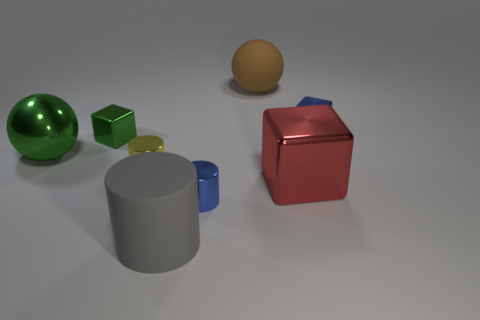Subtract all tiny green blocks. How many blocks are left? 2 Subtract all brown spheres. How many spheres are left? 1 Subtract 1 spheres. How many spheres are left? 1 Add 1 large cylinders. How many objects exist? 9 Subtract all cylinders. How many objects are left? 5 Subtract all tiny yellow rubber balls. Subtract all gray cylinders. How many objects are left? 7 Add 1 large red metal things. How many large red metal things are left? 2 Add 6 blue rubber blocks. How many blue rubber blocks exist? 6 Subtract 0 brown blocks. How many objects are left? 8 Subtract all green balls. Subtract all gray cylinders. How many balls are left? 1 